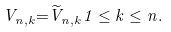Convert formula to latex. <formula><loc_0><loc_0><loc_500><loc_500>{ V } _ { n , k } { = } \widetilde { V } _ { n , k } 1 \leq k \leq n .</formula> 